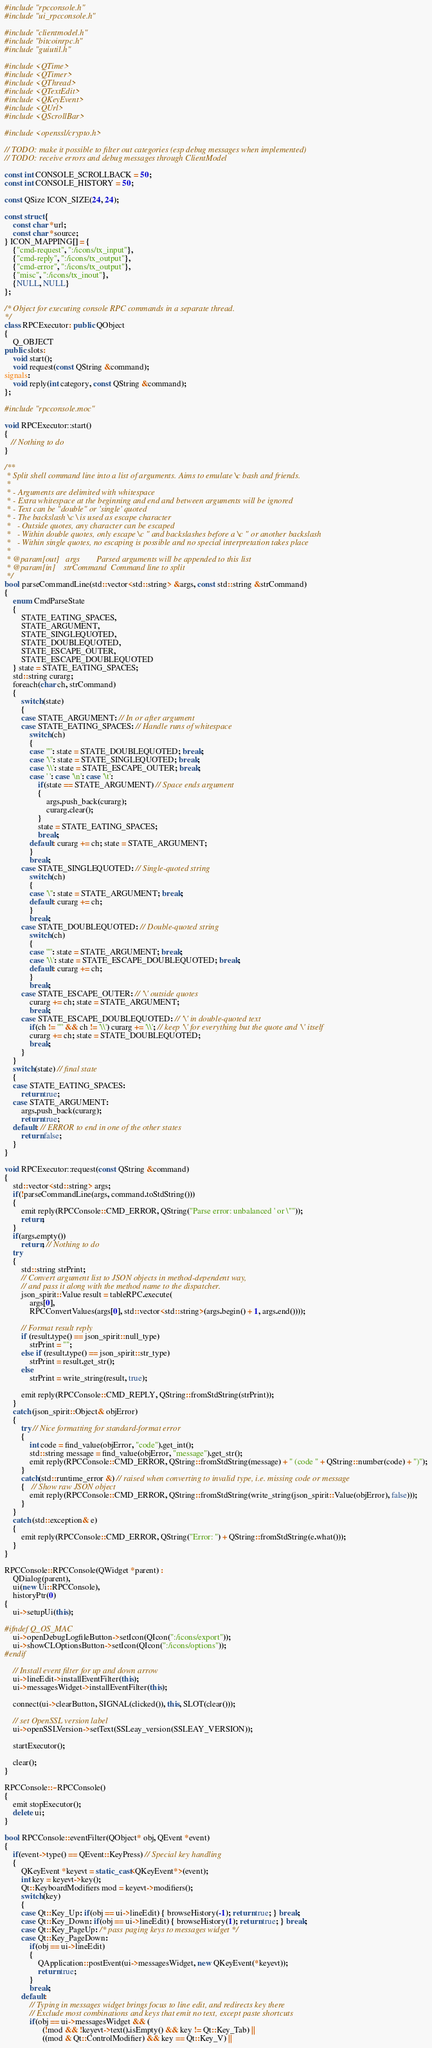<code> <loc_0><loc_0><loc_500><loc_500><_C++_>#include "rpcconsole.h"
#include "ui_rpcconsole.h"

#include "clientmodel.h"
#include "bitcoinrpc.h"
#include "guiutil.h"

#include <QTime>
#include <QTimer>
#include <QThread>
#include <QTextEdit>
#include <QKeyEvent>
#include <QUrl>
#include <QScrollBar>

#include <openssl/crypto.h>

// TODO: make it possible to filter out categories (esp debug messages when implemented)
// TODO: receive errors and debug messages through ClientModel

const int CONSOLE_SCROLLBACK = 50;
const int CONSOLE_HISTORY = 50;

const QSize ICON_SIZE(24, 24);

const struct {
    const char *url;
    const char *source;
} ICON_MAPPING[] = {
    {"cmd-request", ":/icons/tx_input"},
    {"cmd-reply", ":/icons/tx_output"},
    {"cmd-error", ":/icons/tx_output"},
    {"misc", ":/icons/tx_inout"},
    {NULL, NULL}
};

/* Object for executing console RPC commands in a separate thread.
*/
class RPCExecutor: public QObject
{
    Q_OBJECT
public slots:
    void start();
    void request(const QString &command);
signals:
    void reply(int category, const QString &command);
};

#include "rpcconsole.moc"

void RPCExecutor::start()
{
   // Nothing to do
}

/**
 * Split shell command line into a list of arguments. Aims to emulate \c bash and friends.
 *
 * - Arguments are delimited with whitespace
 * - Extra whitespace at the beginning and end and between arguments will be ignored
 * - Text can be "double" or 'single' quoted
 * - The backslash \c \ is used as escape character
 *   - Outside quotes, any character can be escaped
 *   - Within double quotes, only escape \c " and backslashes before a \c " or another backslash
 *   - Within single quotes, no escaping is possible and no special interpretation takes place
 *
 * @param[out]   args        Parsed arguments will be appended to this list
 * @param[in]    strCommand  Command line to split
 */
bool parseCommandLine(std::vector<std::string> &args, const std::string &strCommand)
{
    enum CmdParseState
    {
        STATE_EATING_SPACES,
        STATE_ARGUMENT,
        STATE_SINGLEQUOTED,
        STATE_DOUBLEQUOTED,
        STATE_ESCAPE_OUTER,
        STATE_ESCAPE_DOUBLEQUOTED
    } state = STATE_EATING_SPACES;
    std::string curarg;
    foreach(char ch, strCommand)
    {
        switch(state)
        {
        case STATE_ARGUMENT: // In or after argument
        case STATE_EATING_SPACES: // Handle runs of whitespace
            switch(ch)
            {
            case '"': state = STATE_DOUBLEQUOTED; break;
            case '\'': state = STATE_SINGLEQUOTED; break;
            case '\\': state = STATE_ESCAPE_OUTER; break;
            case ' ': case '\n': case '\t':
                if(state == STATE_ARGUMENT) // Space ends argument
                {
                    args.push_back(curarg);
                    curarg.clear();
                }
                state = STATE_EATING_SPACES;
                break;
            default: curarg += ch; state = STATE_ARGUMENT;
            }
            break;
        case STATE_SINGLEQUOTED: // Single-quoted string
            switch(ch)
            {
            case '\'': state = STATE_ARGUMENT; break;
            default: curarg += ch;
            }
            break;
        case STATE_DOUBLEQUOTED: // Double-quoted string
            switch(ch)
            {
            case '"': state = STATE_ARGUMENT; break;
            case '\\': state = STATE_ESCAPE_DOUBLEQUOTED; break;
            default: curarg += ch;
            }
            break;
        case STATE_ESCAPE_OUTER: // '\' outside quotes
            curarg += ch; state = STATE_ARGUMENT;
            break;
        case STATE_ESCAPE_DOUBLEQUOTED: // '\' in double-quoted text
            if(ch != '"' && ch != '\\') curarg += '\\'; // keep '\' for everything but the quote and '\' itself
            curarg += ch; state = STATE_DOUBLEQUOTED;
            break;
        }
    }
    switch(state) // final state
    {
    case STATE_EATING_SPACES:
        return true;
    case STATE_ARGUMENT:
        args.push_back(curarg);
        return true;
    default: // ERROR to end in one of the other states
        return false;
    }
}

void RPCExecutor::request(const QString &command)
{
    std::vector<std::string> args;
    if(!parseCommandLine(args, command.toStdString()))
    {
        emit reply(RPCConsole::CMD_ERROR, QString("Parse error: unbalanced ' or \""));
        return;
    }
    if(args.empty())
        return; // Nothing to do
    try
    {
        std::string strPrint;
        // Convert argument list to JSON objects in method-dependent way,
        // and pass it along with the method name to the dispatcher.
        json_spirit::Value result = tableRPC.execute(
            args[0],
            RPCConvertValues(args[0], std::vector<std::string>(args.begin() + 1, args.end())));

        // Format result reply
        if (result.type() == json_spirit::null_type)
            strPrint = "";
        else if (result.type() == json_spirit::str_type)
            strPrint = result.get_str();
        else
            strPrint = write_string(result, true);

        emit reply(RPCConsole::CMD_REPLY, QString::fromStdString(strPrint));
    }
    catch (json_spirit::Object& objError)
    {
        try // Nice formatting for standard-format error
        {
            int code = find_value(objError, "code").get_int();
            std::string message = find_value(objError, "message").get_str();
            emit reply(RPCConsole::CMD_ERROR, QString::fromStdString(message) + " (code " + QString::number(code) + ")");
        }
        catch(std::runtime_error &) // raised when converting to invalid type, i.e. missing code or message
        {   // Show raw JSON object
            emit reply(RPCConsole::CMD_ERROR, QString::fromStdString(write_string(json_spirit::Value(objError), false)));
        }
    }
    catch (std::exception& e)
    {
        emit reply(RPCConsole::CMD_ERROR, QString("Error: ") + QString::fromStdString(e.what()));
    }
}

RPCConsole::RPCConsole(QWidget *parent) :
    QDialog(parent),
    ui(new Ui::RPCConsole),
    historyPtr(0)
{
    ui->setupUi(this);

#ifndef Q_OS_MAC
    ui->openDebugLogfileButton->setIcon(QIcon(":/icons/export"));
    ui->showCLOptionsButton->setIcon(QIcon(":/icons/options"));
#endif

    // Install event filter for up and down arrow
    ui->lineEdit->installEventFilter(this);
    ui->messagesWidget->installEventFilter(this);

    connect(ui->clearButton, SIGNAL(clicked()), this, SLOT(clear()));

    // set OpenSSL version label
    ui->openSSLVersion->setText(SSLeay_version(SSLEAY_VERSION));

    startExecutor();

    clear();
}

RPCConsole::~RPCConsole()
{
    emit stopExecutor();
    delete ui;
}

bool RPCConsole::eventFilter(QObject* obj, QEvent *event)
{
    if(event->type() == QEvent::KeyPress) // Special key handling
    {
        QKeyEvent *keyevt = static_cast<QKeyEvent*>(event);
        int key = keyevt->key();
        Qt::KeyboardModifiers mod = keyevt->modifiers();
        switch(key)
        {
        case Qt::Key_Up: if(obj == ui->lineEdit) { browseHistory(-1); return true; } break;
        case Qt::Key_Down: if(obj == ui->lineEdit) { browseHistory(1); return true; } break;
        case Qt::Key_PageUp: /* pass paging keys to messages widget */
        case Qt::Key_PageDown:
            if(obj == ui->lineEdit)
            {
                QApplication::postEvent(ui->messagesWidget, new QKeyEvent(*keyevt));
                return true;
            }
            break;
        default:
            // Typing in messages widget brings focus to line edit, and redirects key there
            // Exclude most combinations and keys that emit no text, except paste shortcuts
            if(obj == ui->messagesWidget && (
                  (!mod && !keyevt->text().isEmpty() && key != Qt::Key_Tab) ||
                  ((mod & Qt::ControlModifier) && key == Qt::Key_V) ||</code> 